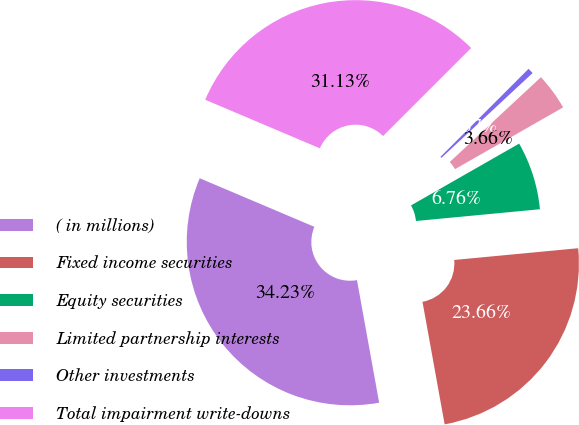<chart> <loc_0><loc_0><loc_500><loc_500><pie_chart><fcel>( in millions)<fcel>Fixed income securities<fcel>Equity securities<fcel>Limited partnership interests<fcel>Other investments<fcel>Total impairment write-downs<nl><fcel>34.23%<fcel>23.66%<fcel>6.76%<fcel>3.66%<fcel>0.57%<fcel>31.13%<nl></chart> 